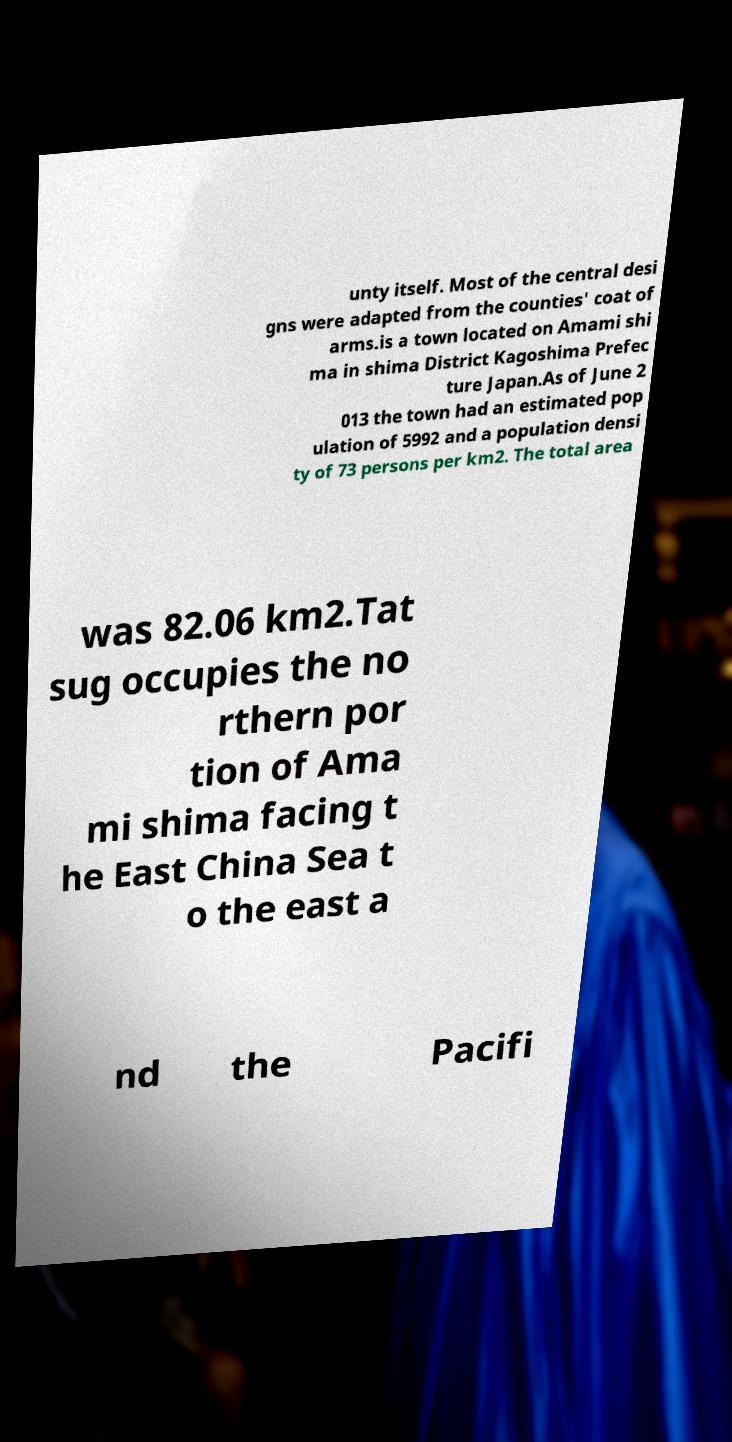I need the written content from this picture converted into text. Can you do that? unty itself. Most of the central desi gns were adapted from the counties' coat of arms.is a town located on Amami shi ma in shima District Kagoshima Prefec ture Japan.As of June 2 013 the town had an estimated pop ulation of 5992 and a population densi ty of 73 persons per km2. The total area was 82.06 km2.Tat sug occupies the no rthern por tion of Ama mi shima facing t he East China Sea t o the east a nd the Pacifi 